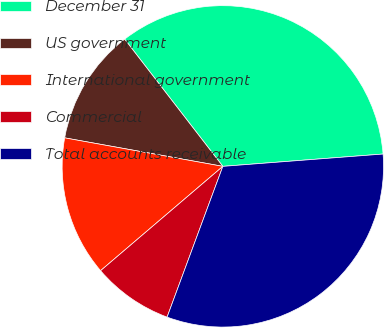Convert chart. <chart><loc_0><loc_0><loc_500><loc_500><pie_chart><fcel>December 31<fcel>US government<fcel>International government<fcel>Commercial<fcel>Total accounts receivable<nl><fcel>34.24%<fcel>11.7%<fcel>14.08%<fcel>8.12%<fcel>31.86%<nl></chart> 